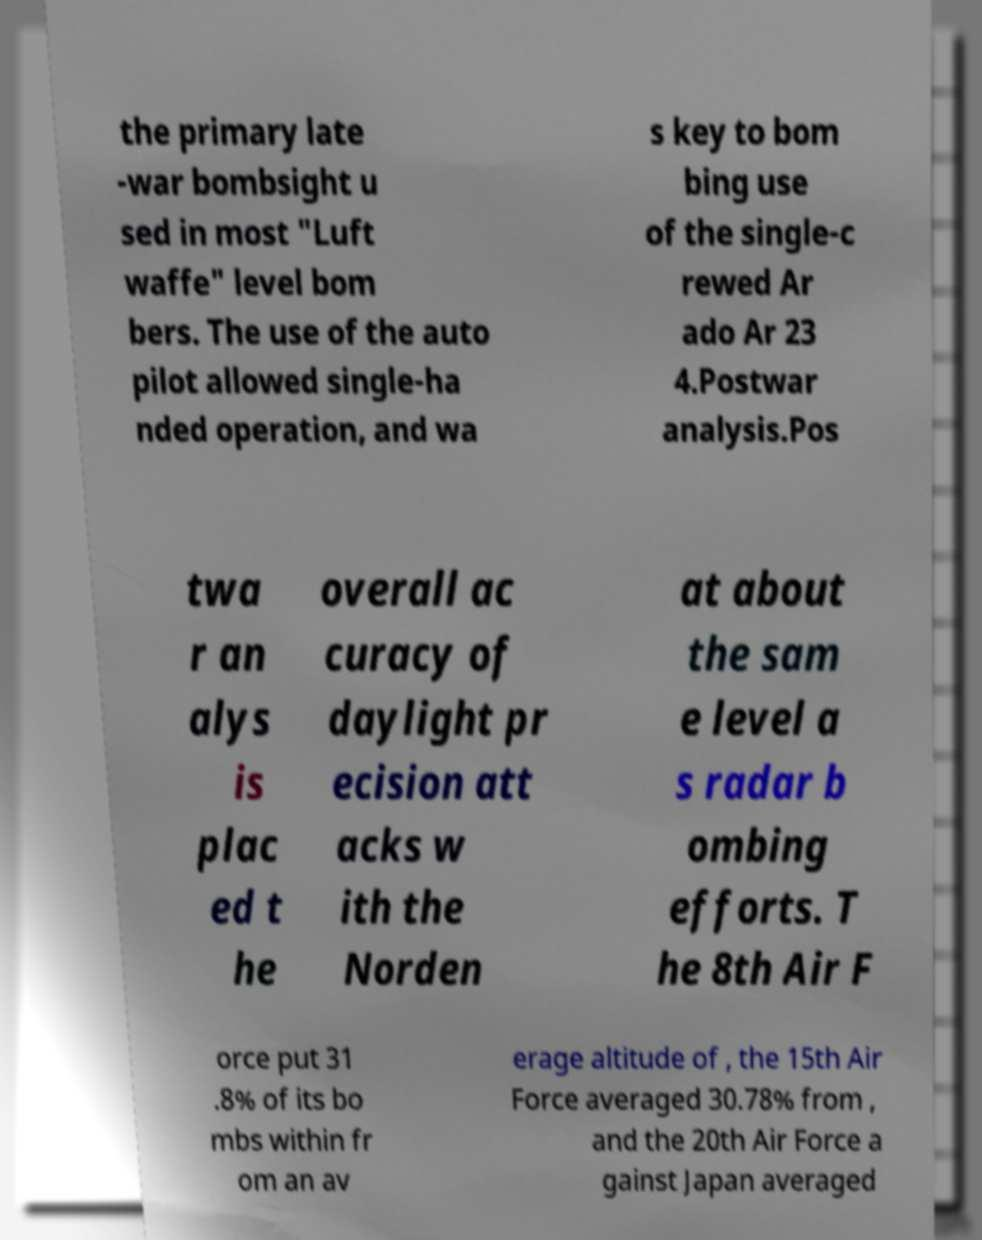What messages or text are displayed in this image? I need them in a readable, typed format. the primary late -war bombsight u sed in most "Luft waffe" level bom bers. The use of the auto pilot allowed single-ha nded operation, and wa s key to bom bing use of the single-c rewed Ar ado Ar 23 4.Postwar analysis.Pos twa r an alys is plac ed t he overall ac curacy of daylight pr ecision att acks w ith the Norden at about the sam e level a s radar b ombing efforts. T he 8th Air F orce put 31 .8% of its bo mbs within fr om an av erage altitude of , the 15th Air Force averaged 30.78% from , and the 20th Air Force a gainst Japan averaged 